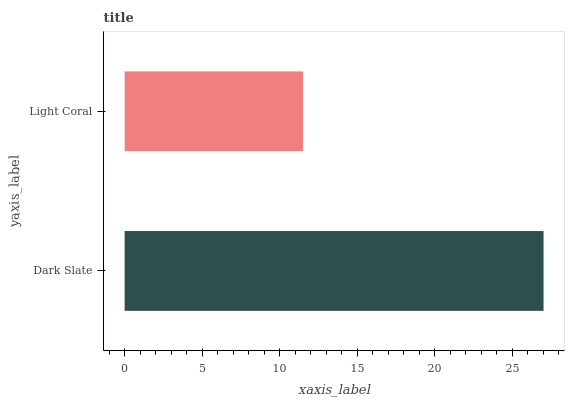Is Light Coral the minimum?
Answer yes or no. Yes. Is Dark Slate the maximum?
Answer yes or no. Yes. Is Light Coral the maximum?
Answer yes or no. No. Is Dark Slate greater than Light Coral?
Answer yes or no. Yes. Is Light Coral less than Dark Slate?
Answer yes or no. Yes. Is Light Coral greater than Dark Slate?
Answer yes or no. No. Is Dark Slate less than Light Coral?
Answer yes or no. No. Is Dark Slate the high median?
Answer yes or no. Yes. Is Light Coral the low median?
Answer yes or no. Yes. Is Light Coral the high median?
Answer yes or no. No. Is Dark Slate the low median?
Answer yes or no. No. 